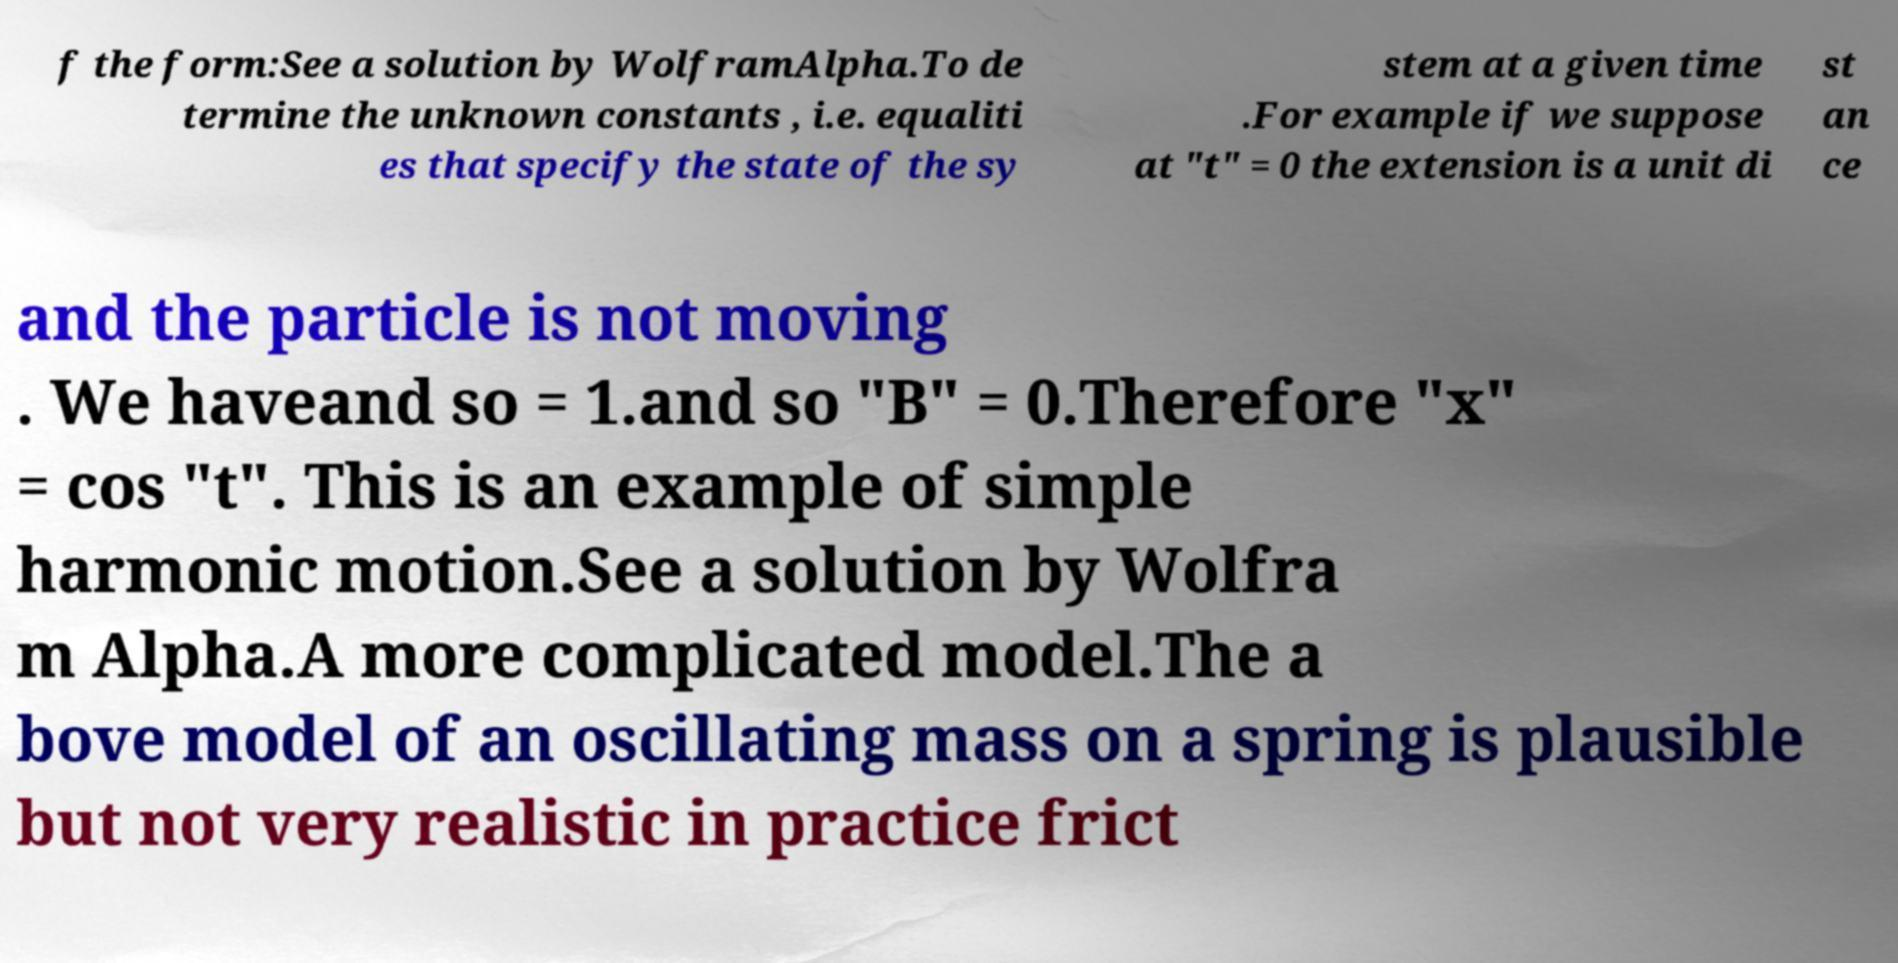There's text embedded in this image that I need extracted. Can you transcribe it verbatim? f the form:See a solution by WolframAlpha.To de termine the unknown constants , i.e. equaliti es that specify the state of the sy stem at a given time .For example if we suppose at "t" = 0 the extension is a unit di st an ce and the particle is not moving . We haveand so = 1.and so "B" = 0.Therefore "x" = cos "t". This is an example of simple harmonic motion.See a solution by Wolfra m Alpha.A more complicated model.The a bove model of an oscillating mass on a spring is plausible but not very realistic in practice frict 